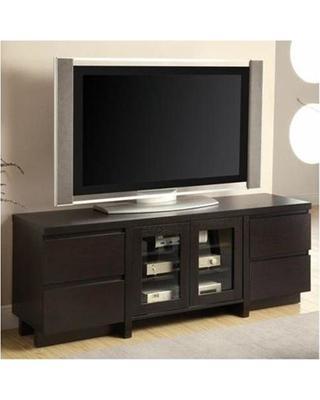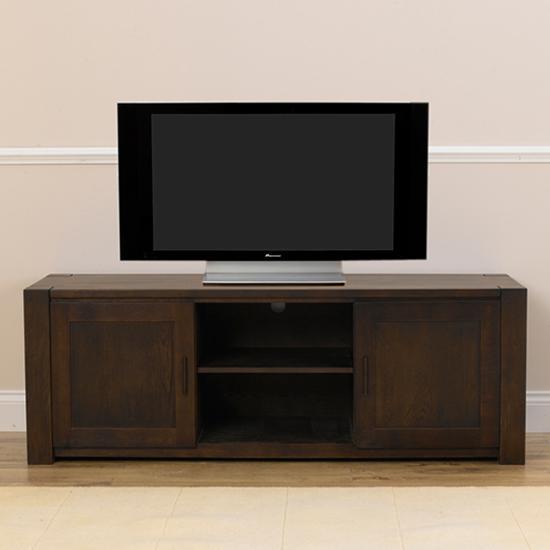The first image is the image on the left, the second image is the image on the right. Considering the images on both sides, is "One picture is sitting on a TV stand next to the TV." valid? Answer yes or no. No. The first image is the image on the left, the second image is the image on the right. Evaluate the accuracy of this statement regarding the images: "One image shows a flatscreen TV on a low-slung stand with solid doors on each end and two open shelves in the middle.". Is it true? Answer yes or no. Yes. 